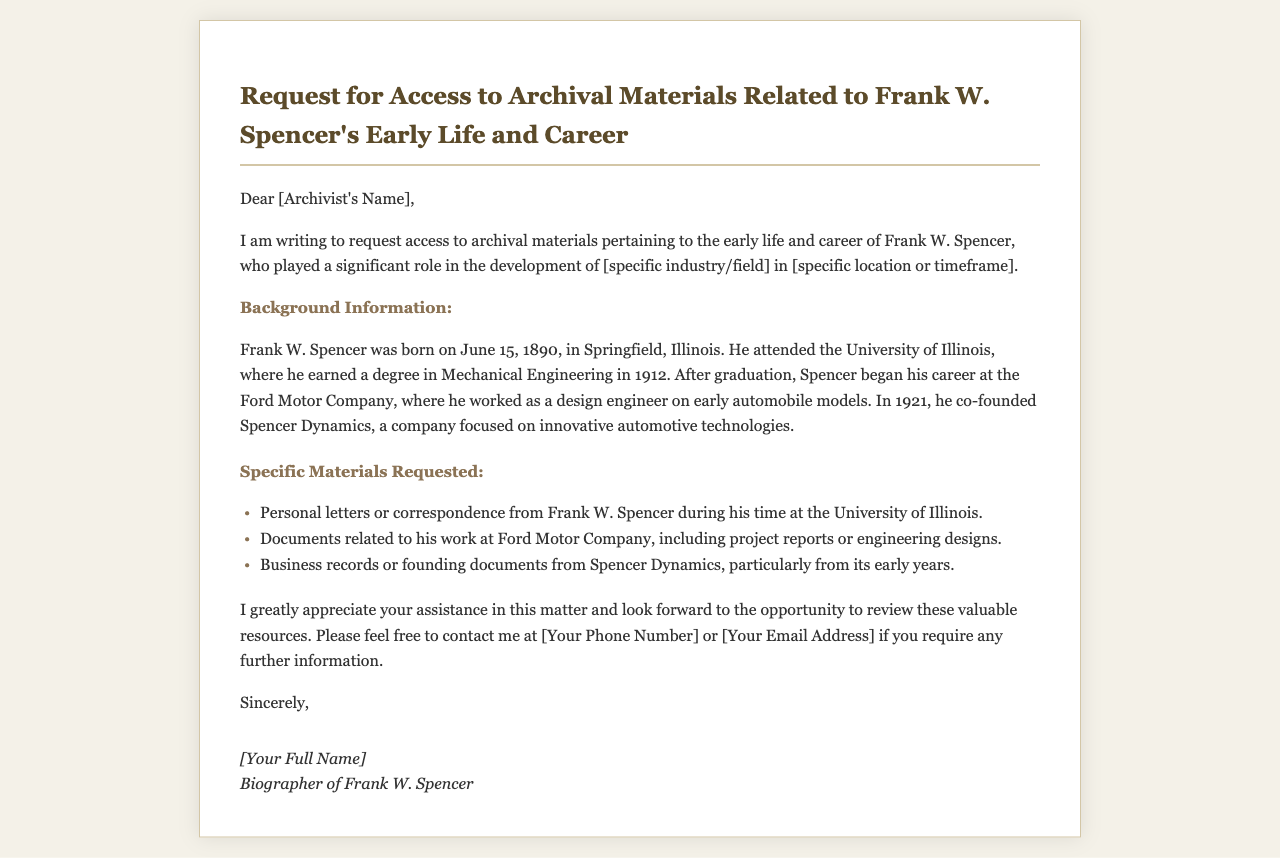What is the date of birth of Frank W. Spencer? The document states that Frank W. Spencer was born on June 15, 1890.
Answer: June 15, 1890 What degree did Frank W. Spencer earn? The document mentions that he earned a degree in Mechanical Engineering.
Answer: Mechanical Engineering Where did Frank W. Spencer co-found a company? The document indicates that he co-founded Spencer Dynamics.
Answer: Spencer Dynamics Which company did he work for after graduation? The document specifies that he worked at the Ford Motor Company.
Answer: Ford Motor Company What is the main purpose of the request? The request is for access to archival materials.
Answer: Access to archival materials What is the time frame mentioned for Frank W. Spencer's career? The document mentions his career in the context of his early life and after graduating in 1912.
Answer: Early life and career after 1912 What type of records related to Spencer Dynamics are requested? The document specifically requests business records or founding documents from Spencer Dynamics.
Answer: Business records or founding documents What is the author’s relationship to Frank W. Spencer? The author identifies themselves as the biographer of Frank W. Spencer.
Answer: Biographer of Frank W. Spencer What is the author’s request regarding personal letters? The author requests personal letters or correspondence from Frank W. Spencer during his time at the University of Illinois.
Answer: Personal letters or correspondence 